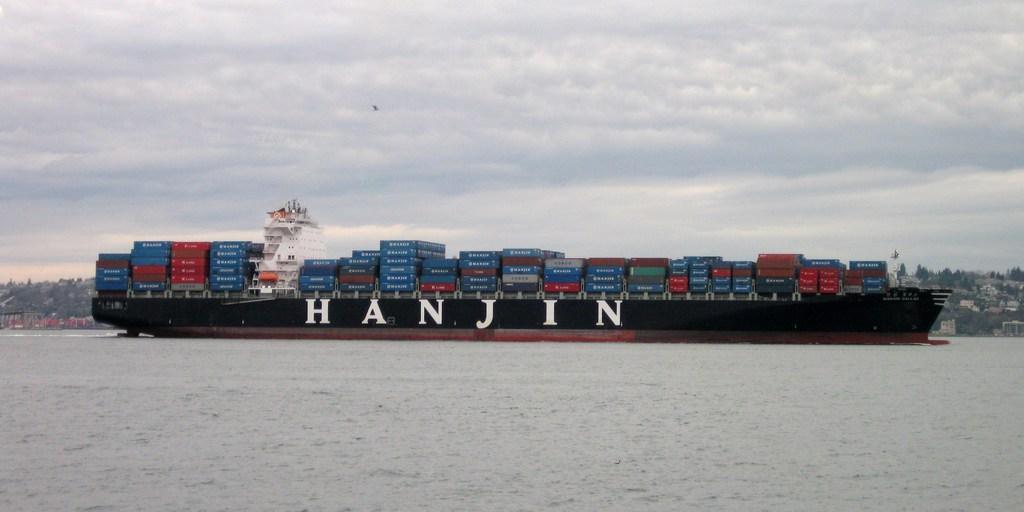Please provide a concise description of this image. This image is taken outdoors. At the top of the image there is the sky with clouds. At the bottom of the image there is a sea with water. In the background there are many houses. There are many trees and plants on the ground. In the middle of the image there is a big ship with a huge luggage in it. There is a text on the ship and there are many containers in the ship. 